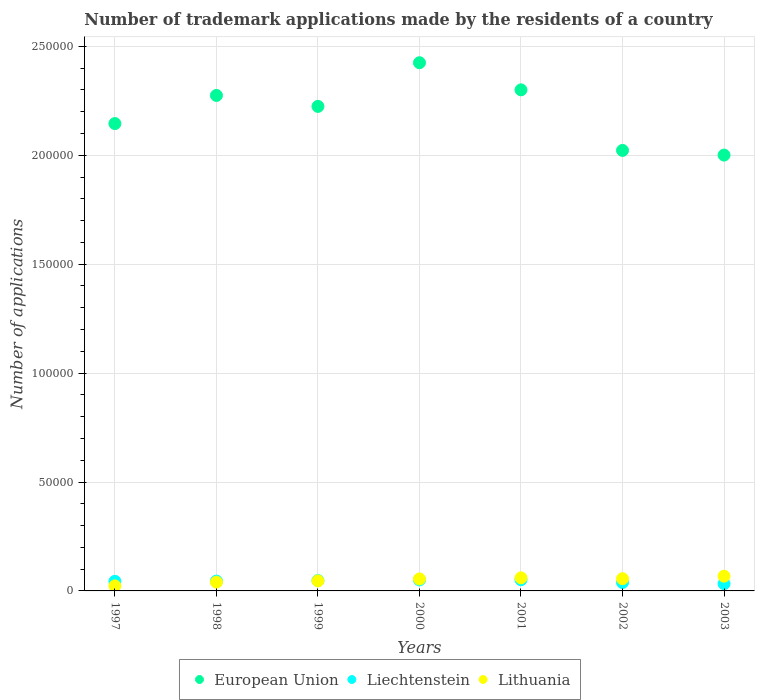Is the number of dotlines equal to the number of legend labels?
Make the answer very short. Yes. What is the number of trademark applications made by the residents in European Union in 2003?
Ensure brevity in your answer.  2.00e+05. Across all years, what is the maximum number of trademark applications made by the residents in European Union?
Your answer should be very brief. 2.42e+05. Across all years, what is the minimum number of trademark applications made by the residents in European Union?
Offer a terse response. 2.00e+05. What is the total number of trademark applications made by the residents in Liechtenstein in the graph?
Keep it short and to the point. 3.11e+04. What is the difference between the number of trademark applications made by the residents in Liechtenstein in 1998 and that in 2002?
Your response must be concise. 666. What is the difference between the number of trademark applications made by the residents in Lithuania in 1999 and the number of trademark applications made by the residents in European Union in 2001?
Offer a very short reply. -2.25e+05. What is the average number of trademark applications made by the residents in European Union per year?
Make the answer very short. 2.20e+05. In the year 2002, what is the difference between the number of trademark applications made by the residents in European Union and number of trademark applications made by the residents in Liechtenstein?
Your answer should be very brief. 1.98e+05. In how many years, is the number of trademark applications made by the residents in Lithuania greater than 160000?
Ensure brevity in your answer.  0. What is the ratio of the number of trademark applications made by the residents in European Union in 1998 to that in 2003?
Your answer should be very brief. 1.14. Is the number of trademark applications made by the residents in Liechtenstein in 1998 less than that in 2002?
Offer a terse response. No. Is the difference between the number of trademark applications made by the residents in European Union in 2000 and 2002 greater than the difference between the number of trademark applications made by the residents in Liechtenstein in 2000 and 2002?
Give a very brief answer. Yes. What is the difference between the highest and the second highest number of trademark applications made by the residents in Liechtenstein?
Give a very brief answer. 90. What is the difference between the highest and the lowest number of trademark applications made by the residents in Liechtenstein?
Your answer should be compact. 1822. In how many years, is the number of trademark applications made by the residents in European Union greater than the average number of trademark applications made by the residents in European Union taken over all years?
Your answer should be very brief. 4. Is the number of trademark applications made by the residents in European Union strictly greater than the number of trademark applications made by the residents in Liechtenstein over the years?
Your answer should be compact. Yes. How many years are there in the graph?
Give a very brief answer. 7. What is the difference between two consecutive major ticks on the Y-axis?
Ensure brevity in your answer.  5.00e+04. Are the values on the major ticks of Y-axis written in scientific E-notation?
Offer a terse response. No. Does the graph contain any zero values?
Provide a short and direct response. No. Does the graph contain grids?
Offer a very short reply. Yes. Where does the legend appear in the graph?
Offer a very short reply. Bottom center. How many legend labels are there?
Provide a short and direct response. 3. What is the title of the graph?
Your answer should be very brief. Number of trademark applications made by the residents of a country. What is the label or title of the Y-axis?
Offer a very short reply. Number of applications. What is the Number of applications in European Union in 1997?
Provide a short and direct response. 2.15e+05. What is the Number of applications in Liechtenstein in 1997?
Keep it short and to the point. 4398. What is the Number of applications of Lithuania in 1997?
Provide a short and direct response. 2316. What is the Number of applications in European Union in 1998?
Your answer should be compact. 2.27e+05. What is the Number of applications in Liechtenstein in 1998?
Your answer should be very brief. 4521. What is the Number of applications in Lithuania in 1998?
Offer a very short reply. 4025. What is the Number of applications in European Union in 1999?
Offer a terse response. 2.22e+05. What is the Number of applications in Liechtenstein in 1999?
Your answer should be compact. 4763. What is the Number of applications in Lithuania in 1999?
Ensure brevity in your answer.  4612. What is the Number of applications of European Union in 2000?
Ensure brevity in your answer.  2.42e+05. What is the Number of applications of Liechtenstein in 2000?
Offer a terse response. 5060. What is the Number of applications in Lithuania in 2000?
Provide a succinct answer. 5500. What is the Number of applications in European Union in 2001?
Provide a succinct answer. 2.30e+05. What is the Number of applications in Liechtenstein in 2001?
Keep it short and to the point. 5150. What is the Number of applications in Lithuania in 2001?
Provide a succinct answer. 5994. What is the Number of applications of European Union in 2002?
Keep it short and to the point. 2.02e+05. What is the Number of applications in Liechtenstein in 2002?
Ensure brevity in your answer.  3855. What is the Number of applications in Lithuania in 2002?
Your answer should be compact. 5602. What is the Number of applications of European Union in 2003?
Keep it short and to the point. 2.00e+05. What is the Number of applications in Liechtenstein in 2003?
Offer a very short reply. 3328. What is the Number of applications of Lithuania in 2003?
Provide a succinct answer. 6770. Across all years, what is the maximum Number of applications of European Union?
Offer a terse response. 2.42e+05. Across all years, what is the maximum Number of applications of Liechtenstein?
Offer a terse response. 5150. Across all years, what is the maximum Number of applications in Lithuania?
Your answer should be compact. 6770. Across all years, what is the minimum Number of applications in European Union?
Provide a succinct answer. 2.00e+05. Across all years, what is the minimum Number of applications in Liechtenstein?
Provide a short and direct response. 3328. Across all years, what is the minimum Number of applications of Lithuania?
Your answer should be very brief. 2316. What is the total Number of applications in European Union in the graph?
Make the answer very short. 1.54e+06. What is the total Number of applications in Liechtenstein in the graph?
Provide a succinct answer. 3.11e+04. What is the total Number of applications of Lithuania in the graph?
Keep it short and to the point. 3.48e+04. What is the difference between the Number of applications of European Union in 1997 and that in 1998?
Your answer should be very brief. -1.29e+04. What is the difference between the Number of applications of Liechtenstein in 1997 and that in 1998?
Keep it short and to the point. -123. What is the difference between the Number of applications in Lithuania in 1997 and that in 1998?
Your answer should be compact. -1709. What is the difference between the Number of applications of European Union in 1997 and that in 1999?
Provide a succinct answer. -7887. What is the difference between the Number of applications of Liechtenstein in 1997 and that in 1999?
Your answer should be very brief. -365. What is the difference between the Number of applications in Lithuania in 1997 and that in 1999?
Provide a succinct answer. -2296. What is the difference between the Number of applications in European Union in 1997 and that in 2000?
Your answer should be very brief. -2.79e+04. What is the difference between the Number of applications in Liechtenstein in 1997 and that in 2000?
Your response must be concise. -662. What is the difference between the Number of applications of Lithuania in 1997 and that in 2000?
Your answer should be compact. -3184. What is the difference between the Number of applications in European Union in 1997 and that in 2001?
Keep it short and to the point. -1.55e+04. What is the difference between the Number of applications in Liechtenstein in 1997 and that in 2001?
Keep it short and to the point. -752. What is the difference between the Number of applications of Lithuania in 1997 and that in 2001?
Give a very brief answer. -3678. What is the difference between the Number of applications of European Union in 1997 and that in 2002?
Offer a very short reply. 1.23e+04. What is the difference between the Number of applications in Liechtenstein in 1997 and that in 2002?
Offer a terse response. 543. What is the difference between the Number of applications in Lithuania in 1997 and that in 2002?
Give a very brief answer. -3286. What is the difference between the Number of applications of European Union in 1997 and that in 2003?
Provide a succinct answer. 1.45e+04. What is the difference between the Number of applications of Liechtenstein in 1997 and that in 2003?
Make the answer very short. 1070. What is the difference between the Number of applications of Lithuania in 1997 and that in 2003?
Give a very brief answer. -4454. What is the difference between the Number of applications of European Union in 1998 and that in 1999?
Provide a short and direct response. 5029. What is the difference between the Number of applications of Liechtenstein in 1998 and that in 1999?
Provide a short and direct response. -242. What is the difference between the Number of applications in Lithuania in 1998 and that in 1999?
Ensure brevity in your answer.  -587. What is the difference between the Number of applications in European Union in 1998 and that in 2000?
Provide a succinct answer. -1.50e+04. What is the difference between the Number of applications in Liechtenstein in 1998 and that in 2000?
Provide a short and direct response. -539. What is the difference between the Number of applications of Lithuania in 1998 and that in 2000?
Offer a terse response. -1475. What is the difference between the Number of applications in European Union in 1998 and that in 2001?
Your answer should be very brief. -2562. What is the difference between the Number of applications in Liechtenstein in 1998 and that in 2001?
Keep it short and to the point. -629. What is the difference between the Number of applications in Lithuania in 1998 and that in 2001?
Keep it short and to the point. -1969. What is the difference between the Number of applications in European Union in 1998 and that in 2002?
Give a very brief answer. 2.52e+04. What is the difference between the Number of applications of Liechtenstein in 1998 and that in 2002?
Give a very brief answer. 666. What is the difference between the Number of applications in Lithuania in 1998 and that in 2002?
Make the answer very short. -1577. What is the difference between the Number of applications in European Union in 1998 and that in 2003?
Provide a succinct answer. 2.74e+04. What is the difference between the Number of applications in Liechtenstein in 1998 and that in 2003?
Provide a succinct answer. 1193. What is the difference between the Number of applications in Lithuania in 1998 and that in 2003?
Offer a very short reply. -2745. What is the difference between the Number of applications of European Union in 1999 and that in 2000?
Your answer should be very brief. -2.00e+04. What is the difference between the Number of applications of Liechtenstein in 1999 and that in 2000?
Provide a succinct answer. -297. What is the difference between the Number of applications of Lithuania in 1999 and that in 2000?
Offer a terse response. -888. What is the difference between the Number of applications of European Union in 1999 and that in 2001?
Your response must be concise. -7591. What is the difference between the Number of applications in Liechtenstein in 1999 and that in 2001?
Your response must be concise. -387. What is the difference between the Number of applications of Lithuania in 1999 and that in 2001?
Give a very brief answer. -1382. What is the difference between the Number of applications in European Union in 1999 and that in 2002?
Keep it short and to the point. 2.02e+04. What is the difference between the Number of applications in Liechtenstein in 1999 and that in 2002?
Provide a short and direct response. 908. What is the difference between the Number of applications in Lithuania in 1999 and that in 2002?
Offer a very short reply. -990. What is the difference between the Number of applications in European Union in 1999 and that in 2003?
Your answer should be compact. 2.24e+04. What is the difference between the Number of applications of Liechtenstein in 1999 and that in 2003?
Offer a very short reply. 1435. What is the difference between the Number of applications in Lithuania in 1999 and that in 2003?
Your response must be concise. -2158. What is the difference between the Number of applications in European Union in 2000 and that in 2001?
Offer a terse response. 1.25e+04. What is the difference between the Number of applications of Liechtenstein in 2000 and that in 2001?
Your response must be concise. -90. What is the difference between the Number of applications in Lithuania in 2000 and that in 2001?
Keep it short and to the point. -494. What is the difference between the Number of applications in European Union in 2000 and that in 2002?
Offer a terse response. 4.03e+04. What is the difference between the Number of applications of Liechtenstein in 2000 and that in 2002?
Your answer should be very brief. 1205. What is the difference between the Number of applications of Lithuania in 2000 and that in 2002?
Your answer should be very brief. -102. What is the difference between the Number of applications in European Union in 2000 and that in 2003?
Keep it short and to the point. 4.24e+04. What is the difference between the Number of applications of Liechtenstein in 2000 and that in 2003?
Offer a very short reply. 1732. What is the difference between the Number of applications of Lithuania in 2000 and that in 2003?
Make the answer very short. -1270. What is the difference between the Number of applications of European Union in 2001 and that in 2002?
Provide a short and direct response. 2.78e+04. What is the difference between the Number of applications of Liechtenstein in 2001 and that in 2002?
Provide a succinct answer. 1295. What is the difference between the Number of applications in Lithuania in 2001 and that in 2002?
Provide a short and direct response. 392. What is the difference between the Number of applications of European Union in 2001 and that in 2003?
Ensure brevity in your answer.  2.99e+04. What is the difference between the Number of applications of Liechtenstein in 2001 and that in 2003?
Provide a succinct answer. 1822. What is the difference between the Number of applications of Lithuania in 2001 and that in 2003?
Keep it short and to the point. -776. What is the difference between the Number of applications in European Union in 2002 and that in 2003?
Your response must be concise. 2142. What is the difference between the Number of applications of Liechtenstein in 2002 and that in 2003?
Ensure brevity in your answer.  527. What is the difference between the Number of applications of Lithuania in 2002 and that in 2003?
Offer a terse response. -1168. What is the difference between the Number of applications of European Union in 1997 and the Number of applications of Liechtenstein in 1998?
Provide a short and direct response. 2.10e+05. What is the difference between the Number of applications in European Union in 1997 and the Number of applications in Lithuania in 1998?
Keep it short and to the point. 2.11e+05. What is the difference between the Number of applications in Liechtenstein in 1997 and the Number of applications in Lithuania in 1998?
Provide a succinct answer. 373. What is the difference between the Number of applications of European Union in 1997 and the Number of applications of Liechtenstein in 1999?
Make the answer very short. 2.10e+05. What is the difference between the Number of applications of European Union in 1997 and the Number of applications of Lithuania in 1999?
Provide a short and direct response. 2.10e+05. What is the difference between the Number of applications of Liechtenstein in 1997 and the Number of applications of Lithuania in 1999?
Ensure brevity in your answer.  -214. What is the difference between the Number of applications of European Union in 1997 and the Number of applications of Liechtenstein in 2000?
Your answer should be compact. 2.09e+05. What is the difference between the Number of applications in European Union in 1997 and the Number of applications in Lithuania in 2000?
Keep it short and to the point. 2.09e+05. What is the difference between the Number of applications in Liechtenstein in 1997 and the Number of applications in Lithuania in 2000?
Make the answer very short. -1102. What is the difference between the Number of applications in European Union in 1997 and the Number of applications in Liechtenstein in 2001?
Ensure brevity in your answer.  2.09e+05. What is the difference between the Number of applications in European Union in 1997 and the Number of applications in Lithuania in 2001?
Keep it short and to the point. 2.09e+05. What is the difference between the Number of applications in Liechtenstein in 1997 and the Number of applications in Lithuania in 2001?
Provide a short and direct response. -1596. What is the difference between the Number of applications of European Union in 1997 and the Number of applications of Liechtenstein in 2002?
Provide a succinct answer. 2.11e+05. What is the difference between the Number of applications in European Union in 1997 and the Number of applications in Lithuania in 2002?
Ensure brevity in your answer.  2.09e+05. What is the difference between the Number of applications in Liechtenstein in 1997 and the Number of applications in Lithuania in 2002?
Give a very brief answer. -1204. What is the difference between the Number of applications of European Union in 1997 and the Number of applications of Liechtenstein in 2003?
Your response must be concise. 2.11e+05. What is the difference between the Number of applications of European Union in 1997 and the Number of applications of Lithuania in 2003?
Your answer should be very brief. 2.08e+05. What is the difference between the Number of applications of Liechtenstein in 1997 and the Number of applications of Lithuania in 2003?
Your answer should be very brief. -2372. What is the difference between the Number of applications of European Union in 1998 and the Number of applications of Liechtenstein in 1999?
Keep it short and to the point. 2.23e+05. What is the difference between the Number of applications in European Union in 1998 and the Number of applications in Lithuania in 1999?
Provide a short and direct response. 2.23e+05. What is the difference between the Number of applications of Liechtenstein in 1998 and the Number of applications of Lithuania in 1999?
Your response must be concise. -91. What is the difference between the Number of applications of European Union in 1998 and the Number of applications of Liechtenstein in 2000?
Provide a succinct answer. 2.22e+05. What is the difference between the Number of applications in European Union in 1998 and the Number of applications in Lithuania in 2000?
Make the answer very short. 2.22e+05. What is the difference between the Number of applications of Liechtenstein in 1998 and the Number of applications of Lithuania in 2000?
Provide a succinct answer. -979. What is the difference between the Number of applications of European Union in 1998 and the Number of applications of Liechtenstein in 2001?
Provide a short and direct response. 2.22e+05. What is the difference between the Number of applications of European Union in 1998 and the Number of applications of Lithuania in 2001?
Offer a very short reply. 2.21e+05. What is the difference between the Number of applications of Liechtenstein in 1998 and the Number of applications of Lithuania in 2001?
Give a very brief answer. -1473. What is the difference between the Number of applications of European Union in 1998 and the Number of applications of Liechtenstein in 2002?
Ensure brevity in your answer.  2.24e+05. What is the difference between the Number of applications in European Union in 1998 and the Number of applications in Lithuania in 2002?
Provide a short and direct response. 2.22e+05. What is the difference between the Number of applications of Liechtenstein in 1998 and the Number of applications of Lithuania in 2002?
Offer a terse response. -1081. What is the difference between the Number of applications of European Union in 1998 and the Number of applications of Liechtenstein in 2003?
Offer a terse response. 2.24e+05. What is the difference between the Number of applications of European Union in 1998 and the Number of applications of Lithuania in 2003?
Give a very brief answer. 2.21e+05. What is the difference between the Number of applications in Liechtenstein in 1998 and the Number of applications in Lithuania in 2003?
Your response must be concise. -2249. What is the difference between the Number of applications in European Union in 1999 and the Number of applications in Liechtenstein in 2000?
Ensure brevity in your answer.  2.17e+05. What is the difference between the Number of applications in European Union in 1999 and the Number of applications in Lithuania in 2000?
Ensure brevity in your answer.  2.17e+05. What is the difference between the Number of applications of Liechtenstein in 1999 and the Number of applications of Lithuania in 2000?
Provide a short and direct response. -737. What is the difference between the Number of applications in European Union in 1999 and the Number of applications in Liechtenstein in 2001?
Offer a terse response. 2.17e+05. What is the difference between the Number of applications in European Union in 1999 and the Number of applications in Lithuania in 2001?
Keep it short and to the point. 2.16e+05. What is the difference between the Number of applications of Liechtenstein in 1999 and the Number of applications of Lithuania in 2001?
Make the answer very short. -1231. What is the difference between the Number of applications of European Union in 1999 and the Number of applications of Liechtenstein in 2002?
Provide a short and direct response. 2.19e+05. What is the difference between the Number of applications in European Union in 1999 and the Number of applications in Lithuania in 2002?
Make the answer very short. 2.17e+05. What is the difference between the Number of applications of Liechtenstein in 1999 and the Number of applications of Lithuania in 2002?
Ensure brevity in your answer.  -839. What is the difference between the Number of applications of European Union in 1999 and the Number of applications of Liechtenstein in 2003?
Give a very brief answer. 2.19e+05. What is the difference between the Number of applications in European Union in 1999 and the Number of applications in Lithuania in 2003?
Your answer should be compact. 2.16e+05. What is the difference between the Number of applications in Liechtenstein in 1999 and the Number of applications in Lithuania in 2003?
Give a very brief answer. -2007. What is the difference between the Number of applications of European Union in 2000 and the Number of applications of Liechtenstein in 2001?
Make the answer very short. 2.37e+05. What is the difference between the Number of applications in European Union in 2000 and the Number of applications in Lithuania in 2001?
Offer a very short reply. 2.36e+05. What is the difference between the Number of applications in Liechtenstein in 2000 and the Number of applications in Lithuania in 2001?
Make the answer very short. -934. What is the difference between the Number of applications of European Union in 2000 and the Number of applications of Liechtenstein in 2002?
Offer a very short reply. 2.39e+05. What is the difference between the Number of applications in European Union in 2000 and the Number of applications in Lithuania in 2002?
Your answer should be very brief. 2.37e+05. What is the difference between the Number of applications of Liechtenstein in 2000 and the Number of applications of Lithuania in 2002?
Your answer should be very brief. -542. What is the difference between the Number of applications of European Union in 2000 and the Number of applications of Liechtenstein in 2003?
Your answer should be compact. 2.39e+05. What is the difference between the Number of applications in European Union in 2000 and the Number of applications in Lithuania in 2003?
Make the answer very short. 2.36e+05. What is the difference between the Number of applications of Liechtenstein in 2000 and the Number of applications of Lithuania in 2003?
Ensure brevity in your answer.  -1710. What is the difference between the Number of applications in European Union in 2001 and the Number of applications in Liechtenstein in 2002?
Provide a succinct answer. 2.26e+05. What is the difference between the Number of applications of European Union in 2001 and the Number of applications of Lithuania in 2002?
Offer a very short reply. 2.24e+05. What is the difference between the Number of applications of Liechtenstein in 2001 and the Number of applications of Lithuania in 2002?
Your answer should be very brief. -452. What is the difference between the Number of applications in European Union in 2001 and the Number of applications in Liechtenstein in 2003?
Provide a succinct answer. 2.27e+05. What is the difference between the Number of applications of European Union in 2001 and the Number of applications of Lithuania in 2003?
Give a very brief answer. 2.23e+05. What is the difference between the Number of applications in Liechtenstein in 2001 and the Number of applications in Lithuania in 2003?
Keep it short and to the point. -1620. What is the difference between the Number of applications of European Union in 2002 and the Number of applications of Liechtenstein in 2003?
Give a very brief answer. 1.99e+05. What is the difference between the Number of applications of European Union in 2002 and the Number of applications of Lithuania in 2003?
Your answer should be compact. 1.95e+05. What is the difference between the Number of applications in Liechtenstein in 2002 and the Number of applications in Lithuania in 2003?
Your answer should be compact. -2915. What is the average Number of applications of European Union per year?
Ensure brevity in your answer.  2.20e+05. What is the average Number of applications in Liechtenstein per year?
Make the answer very short. 4439.29. What is the average Number of applications in Lithuania per year?
Keep it short and to the point. 4974.14. In the year 1997, what is the difference between the Number of applications of European Union and Number of applications of Liechtenstein?
Keep it short and to the point. 2.10e+05. In the year 1997, what is the difference between the Number of applications in European Union and Number of applications in Lithuania?
Provide a succinct answer. 2.12e+05. In the year 1997, what is the difference between the Number of applications of Liechtenstein and Number of applications of Lithuania?
Keep it short and to the point. 2082. In the year 1998, what is the difference between the Number of applications in European Union and Number of applications in Liechtenstein?
Your answer should be very brief. 2.23e+05. In the year 1998, what is the difference between the Number of applications in European Union and Number of applications in Lithuania?
Ensure brevity in your answer.  2.23e+05. In the year 1998, what is the difference between the Number of applications of Liechtenstein and Number of applications of Lithuania?
Ensure brevity in your answer.  496. In the year 1999, what is the difference between the Number of applications in European Union and Number of applications in Liechtenstein?
Provide a succinct answer. 2.18e+05. In the year 1999, what is the difference between the Number of applications in European Union and Number of applications in Lithuania?
Ensure brevity in your answer.  2.18e+05. In the year 1999, what is the difference between the Number of applications in Liechtenstein and Number of applications in Lithuania?
Keep it short and to the point. 151. In the year 2000, what is the difference between the Number of applications in European Union and Number of applications in Liechtenstein?
Make the answer very short. 2.37e+05. In the year 2000, what is the difference between the Number of applications of European Union and Number of applications of Lithuania?
Ensure brevity in your answer.  2.37e+05. In the year 2000, what is the difference between the Number of applications in Liechtenstein and Number of applications in Lithuania?
Your answer should be compact. -440. In the year 2001, what is the difference between the Number of applications of European Union and Number of applications of Liechtenstein?
Offer a very short reply. 2.25e+05. In the year 2001, what is the difference between the Number of applications of European Union and Number of applications of Lithuania?
Keep it short and to the point. 2.24e+05. In the year 2001, what is the difference between the Number of applications of Liechtenstein and Number of applications of Lithuania?
Keep it short and to the point. -844. In the year 2002, what is the difference between the Number of applications of European Union and Number of applications of Liechtenstein?
Provide a succinct answer. 1.98e+05. In the year 2002, what is the difference between the Number of applications in European Union and Number of applications in Lithuania?
Your answer should be very brief. 1.97e+05. In the year 2002, what is the difference between the Number of applications in Liechtenstein and Number of applications in Lithuania?
Provide a short and direct response. -1747. In the year 2003, what is the difference between the Number of applications in European Union and Number of applications in Liechtenstein?
Offer a very short reply. 1.97e+05. In the year 2003, what is the difference between the Number of applications of European Union and Number of applications of Lithuania?
Make the answer very short. 1.93e+05. In the year 2003, what is the difference between the Number of applications in Liechtenstein and Number of applications in Lithuania?
Your answer should be compact. -3442. What is the ratio of the Number of applications of European Union in 1997 to that in 1998?
Your answer should be very brief. 0.94. What is the ratio of the Number of applications in Liechtenstein in 1997 to that in 1998?
Provide a short and direct response. 0.97. What is the ratio of the Number of applications of Lithuania in 1997 to that in 1998?
Keep it short and to the point. 0.58. What is the ratio of the Number of applications of European Union in 1997 to that in 1999?
Provide a short and direct response. 0.96. What is the ratio of the Number of applications of Liechtenstein in 1997 to that in 1999?
Your response must be concise. 0.92. What is the ratio of the Number of applications in Lithuania in 1997 to that in 1999?
Provide a succinct answer. 0.5. What is the ratio of the Number of applications in European Union in 1997 to that in 2000?
Your answer should be compact. 0.88. What is the ratio of the Number of applications in Liechtenstein in 1997 to that in 2000?
Make the answer very short. 0.87. What is the ratio of the Number of applications of Lithuania in 1997 to that in 2000?
Offer a very short reply. 0.42. What is the ratio of the Number of applications of European Union in 1997 to that in 2001?
Offer a very short reply. 0.93. What is the ratio of the Number of applications of Liechtenstein in 1997 to that in 2001?
Make the answer very short. 0.85. What is the ratio of the Number of applications in Lithuania in 1997 to that in 2001?
Make the answer very short. 0.39. What is the ratio of the Number of applications of European Union in 1997 to that in 2002?
Keep it short and to the point. 1.06. What is the ratio of the Number of applications of Liechtenstein in 1997 to that in 2002?
Keep it short and to the point. 1.14. What is the ratio of the Number of applications in Lithuania in 1997 to that in 2002?
Provide a short and direct response. 0.41. What is the ratio of the Number of applications in European Union in 1997 to that in 2003?
Make the answer very short. 1.07. What is the ratio of the Number of applications of Liechtenstein in 1997 to that in 2003?
Provide a short and direct response. 1.32. What is the ratio of the Number of applications of Lithuania in 1997 to that in 2003?
Provide a succinct answer. 0.34. What is the ratio of the Number of applications in European Union in 1998 to that in 1999?
Ensure brevity in your answer.  1.02. What is the ratio of the Number of applications of Liechtenstein in 1998 to that in 1999?
Your answer should be very brief. 0.95. What is the ratio of the Number of applications in Lithuania in 1998 to that in 1999?
Keep it short and to the point. 0.87. What is the ratio of the Number of applications in European Union in 1998 to that in 2000?
Your response must be concise. 0.94. What is the ratio of the Number of applications in Liechtenstein in 1998 to that in 2000?
Provide a short and direct response. 0.89. What is the ratio of the Number of applications of Lithuania in 1998 to that in 2000?
Your answer should be compact. 0.73. What is the ratio of the Number of applications in European Union in 1998 to that in 2001?
Offer a terse response. 0.99. What is the ratio of the Number of applications of Liechtenstein in 1998 to that in 2001?
Ensure brevity in your answer.  0.88. What is the ratio of the Number of applications of Lithuania in 1998 to that in 2001?
Your response must be concise. 0.67. What is the ratio of the Number of applications in European Union in 1998 to that in 2002?
Give a very brief answer. 1.12. What is the ratio of the Number of applications of Liechtenstein in 1998 to that in 2002?
Provide a succinct answer. 1.17. What is the ratio of the Number of applications in Lithuania in 1998 to that in 2002?
Your answer should be compact. 0.72. What is the ratio of the Number of applications in European Union in 1998 to that in 2003?
Offer a terse response. 1.14. What is the ratio of the Number of applications of Liechtenstein in 1998 to that in 2003?
Make the answer very short. 1.36. What is the ratio of the Number of applications in Lithuania in 1998 to that in 2003?
Give a very brief answer. 0.59. What is the ratio of the Number of applications of European Union in 1999 to that in 2000?
Your response must be concise. 0.92. What is the ratio of the Number of applications of Liechtenstein in 1999 to that in 2000?
Your answer should be compact. 0.94. What is the ratio of the Number of applications of Lithuania in 1999 to that in 2000?
Offer a terse response. 0.84. What is the ratio of the Number of applications in Liechtenstein in 1999 to that in 2001?
Your answer should be compact. 0.92. What is the ratio of the Number of applications in Lithuania in 1999 to that in 2001?
Provide a short and direct response. 0.77. What is the ratio of the Number of applications in European Union in 1999 to that in 2002?
Keep it short and to the point. 1.1. What is the ratio of the Number of applications in Liechtenstein in 1999 to that in 2002?
Give a very brief answer. 1.24. What is the ratio of the Number of applications in Lithuania in 1999 to that in 2002?
Ensure brevity in your answer.  0.82. What is the ratio of the Number of applications in European Union in 1999 to that in 2003?
Offer a very short reply. 1.11. What is the ratio of the Number of applications of Liechtenstein in 1999 to that in 2003?
Your answer should be very brief. 1.43. What is the ratio of the Number of applications of Lithuania in 1999 to that in 2003?
Give a very brief answer. 0.68. What is the ratio of the Number of applications of European Union in 2000 to that in 2001?
Make the answer very short. 1.05. What is the ratio of the Number of applications of Liechtenstein in 2000 to that in 2001?
Your answer should be compact. 0.98. What is the ratio of the Number of applications of Lithuania in 2000 to that in 2001?
Make the answer very short. 0.92. What is the ratio of the Number of applications of European Union in 2000 to that in 2002?
Provide a short and direct response. 1.2. What is the ratio of the Number of applications in Liechtenstein in 2000 to that in 2002?
Offer a very short reply. 1.31. What is the ratio of the Number of applications in Lithuania in 2000 to that in 2002?
Give a very brief answer. 0.98. What is the ratio of the Number of applications in European Union in 2000 to that in 2003?
Offer a very short reply. 1.21. What is the ratio of the Number of applications in Liechtenstein in 2000 to that in 2003?
Your answer should be very brief. 1.52. What is the ratio of the Number of applications in Lithuania in 2000 to that in 2003?
Provide a short and direct response. 0.81. What is the ratio of the Number of applications of European Union in 2001 to that in 2002?
Your answer should be compact. 1.14. What is the ratio of the Number of applications of Liechtenstein in 2001 to that in 2002?
Ensure brevity in your answer.  1.34. What is the ratio of the Number of applications of Lithuania in 2001 to that in 2002?
Your answer should be compact. 1.07. What is the ratio of the Number of applications in European Union in 2001 to that in 2003?
Ensure brevity in your answer.  1.15. What is the ratio of the Number of applications in Liechtenstein in 2001 to that in 2003?
Provide a short and direct response. 1.55. What is the ratio of the Number of applications of Lithuania in 2001 to that in 2003?
Keep it short and to the point. 0.89. What is the ratio of the Number of applications of European Union in 2002 to that in 2003?
Your answer should be very brief. 1.01. What is the ratio of the Number of applications of Liechtenstein in 2002 to that in 2003?
Provide a succinct answer. 1.16. What is the ratio of the Number of applications in Lithuania in 2002 to that in 2003?
Your response must be concise. 0.83. What is the difference between the highest and the second highest Number of applications of European Union?
Make the answer very short. 1.25e+04. What is the difference between the highest and the second highest Number of applications of Lithuania?
Offer a terse response. 776. What is the difference between the highest and the lowest Number of applications in European Union?
Your answer should be very brief. 4.24e+04. What is the difference between the highest and the lowest Number of applications of Liechtenstein?
Offer a very short reply. 1822. What is the difference between the highest and the lowest Number of applications in Lithuania?
Ensure brevity in your answer.  4454. 